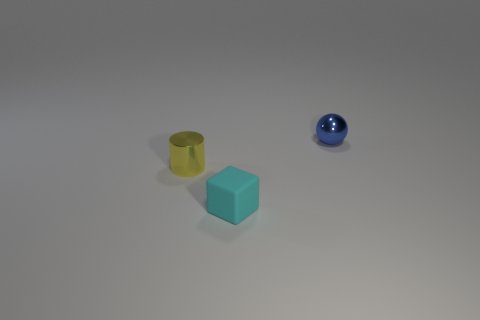Add 1 small cyan metallic balls. How many objects exist? 4 Subtract all blocks. How many objects are left? 2 Add 2 small balls. How many small balls exist? 3 Subtract 0 purple spheres. How many objects are left? 3 Subtract all large gray cylinders. Subtract all small blue metallic spheres. How many objects are left? 2 Add 3 small yellow shiny cylinders. How many small yellow shiny cylinders are left? 4 